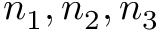<formula> <loc_0><loc_0><loc_500><loc_500>n _ { 1 } , n _ { 2 } , n _ { 3 }</formula> 